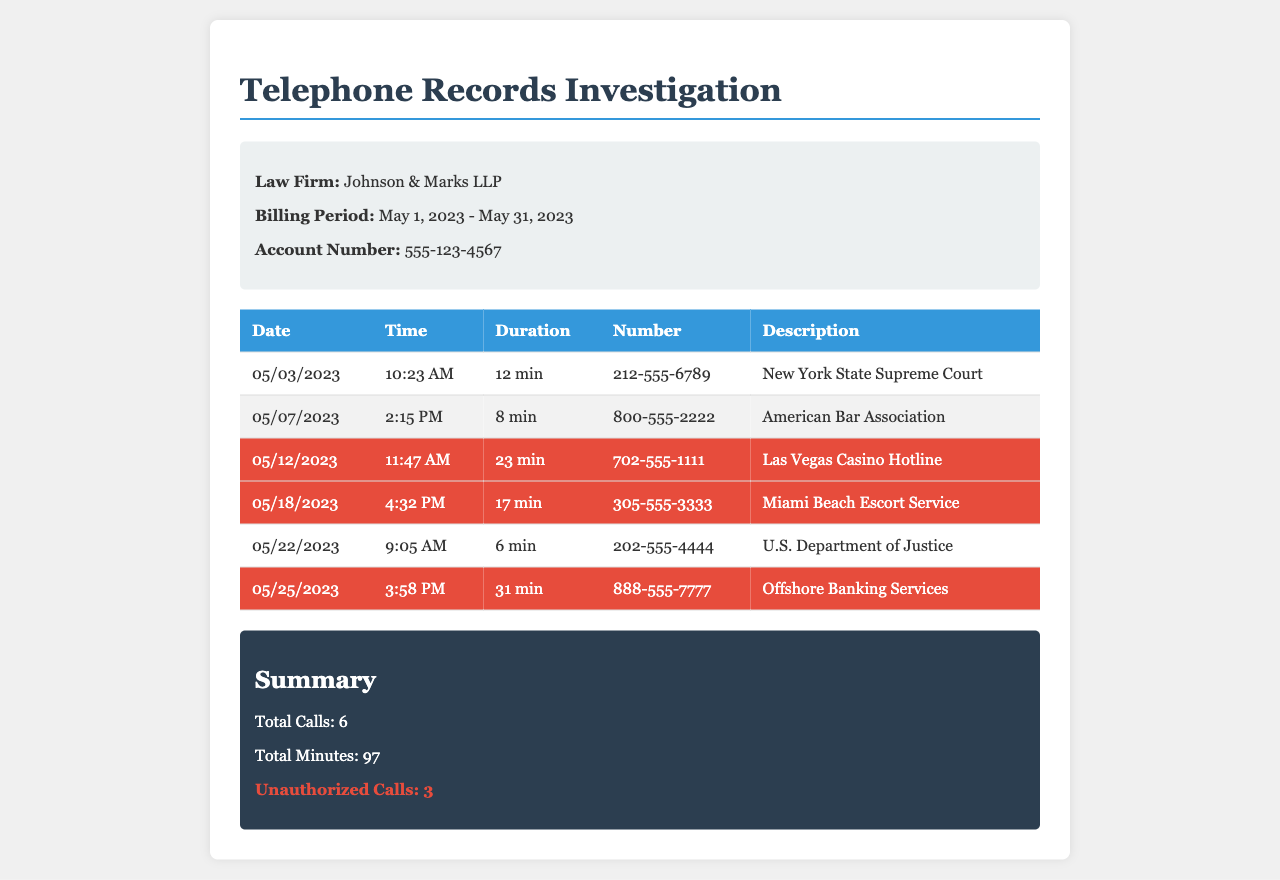what is the name of the law firm? The law firm's name is stated in the header section of the document.
Answer: Johnson & Marks LLP what is the billing period? The billing period is mentioned in the header section, specifying the range of dates.
Answer: May 1, 2023 - May 31, 2023 how many total calls are recorded? The total number of calls is summarized at the end of the document.
Answer: 6 how many unauthorized calls are present? The unauthorized calls are highlighted in the summary section, which specifies their count.
Answer: 3 which number corresponds to the Las Vegas Casino Hotline? The number is listed in the row for that specific call in the table.
Answer: 702-555-1111 what time did the call to the American Bar Association occur? The time for this call is provided in the respective row of the table.
Answer: 2:15 PM what was the duration of the call to the Miami Beach Escort Service? The duration is included in the table row for that call.
Answer: 17 min how many minutes total did the unauthorized calls account for? The total minutes can be calculated by summing the durations of the unauthorized calls listed.
Answer: 71 min what is the description for the call on May 25, 2023? The description is specified in the row for that date in the table.
Answer: Offshore Banking Services 